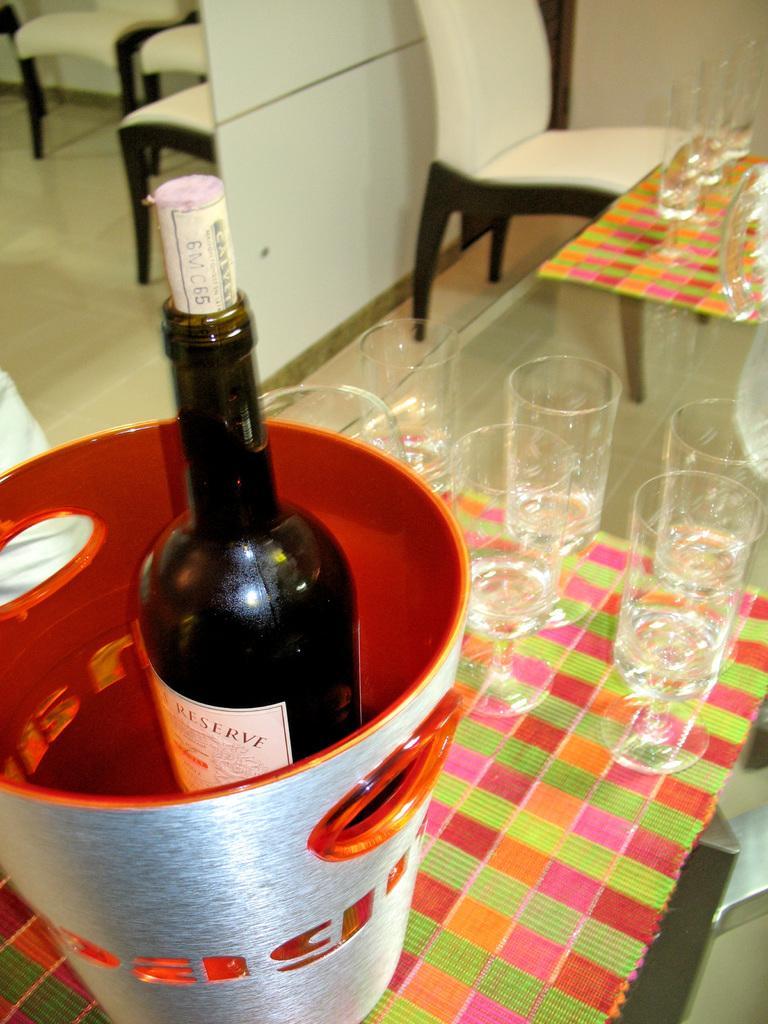Please provide a concise description of this image. In this image there is a wine bottle is kept in to a tub as we can see at left side of this image and there are some glasses arranged on the surface is at right side of this image and there are some chairs at top of this image and there are some glasses arranged on a table is at top right corner of this image. 